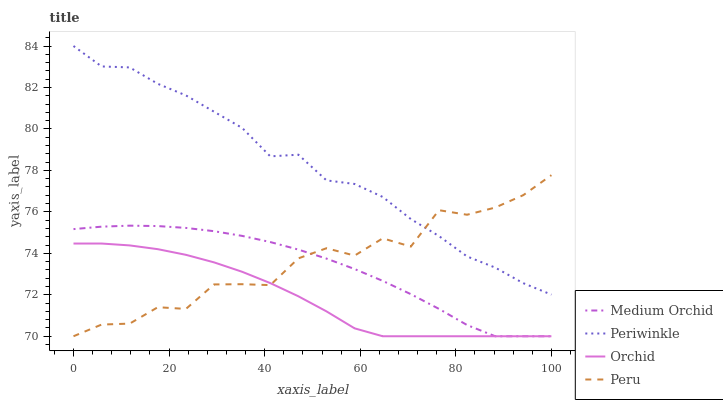Does Orchid have the minimum area under the curve?
Answer yes or no. Yes. Does Periwinkle have the maximum area under the curve?
Answer yes or no. Yes. Does Peru have the minimum area under the curve?
Answer yes or no. No. Does Peru have the maximum area under the curve?
Answer yes or no. No. Is Orchid the smoothest?
Answer yes or no. Yes. Is Peru the roughest?
Answer yes or no. Yes. Is Periwinkle the smoothest?
Answer yes or no. No. Is Periwinkle the roughest?
Answer yes or no. No. Does Periwinkle have the lowest value?
Answer yes or no. No. Does Periwinkle have the highest value?
Answer yes or no. Yes. Does Peru have the highest value?
Answer yes or no. No. Is Medium Orchid less than Periwinkle?
Answer yes or no. Yes. Is Periwinkle greater than Medium Orchid?
Answer yes or no. Yes. Does Medium Orchid intersect Periwinkle?
Answer yes or no. No. 